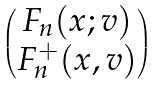Convert formula to latex. <formula><loc_0><loc_0><loc_500><loc_500>\begin{pmatrix} F _ { n } ( x ; v ) \\ F ^ { + } _ { n } ( x , v ) \end{pmatrix}</formula> 